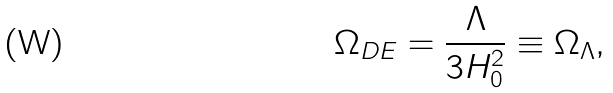<formula> <loc_0><loc_0><loc_500><loc_500>\Omega _ { D E } = \frac { \Lambda } { 3 H _ { 0 } ^ { 2 } } \equiv \Omega _ { \Lambda } ,</formula> 